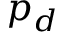Convert formula to latex. <formula><loc_0><loc_0><loc_500><loc_500>p _ { d }</formula> 